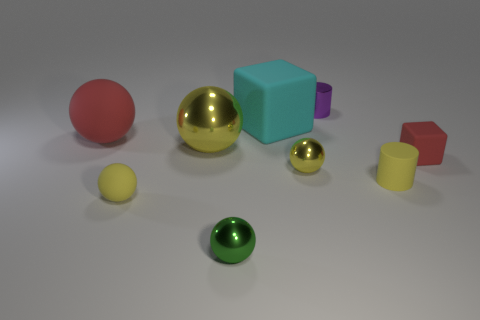Subtract all brown blocks. How many yellow spheres are left? 3 Add 1 spheres. How many objects exist? 10 Subtract all cylinders. How many objects are left? 7 Add 7 red matte balls. How many red matte balls are left? 8 Add 2 large green rubber balls. How many large green rubber balls exist? 2 Subtract 0 purple spheres. How many objects are left? 9 Subtract all purple shiny cylinders. Subtract all rubber things. How many objects are left? 3 